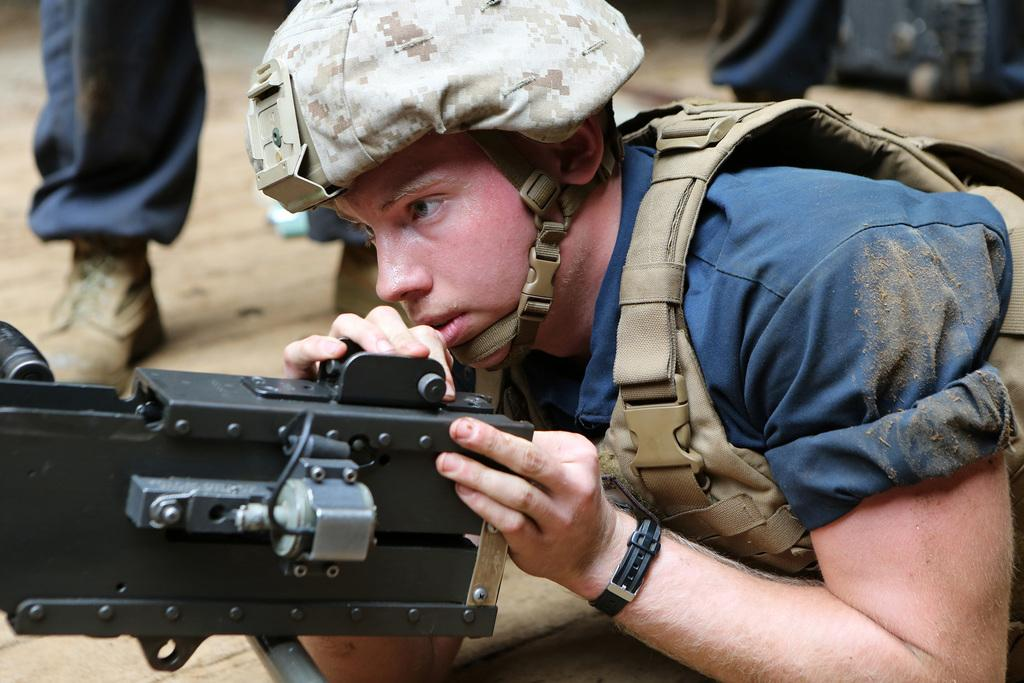What is the main subject of the image? The main subject of the image is a person lying on the ground. What is the person holding in the image? The person is holding a machine gun. Can you describe the background of the image? There are persons standing in the background of the image. What type of truck can be seen driving through the hole in the image? There is no truck or hole present in the image; it features a person lying on the ground holding a machine gun and other persons standing in the background. 